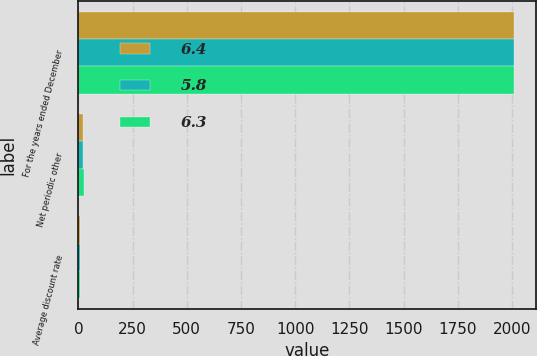Convert chart to OTSL. <chart><loc_0><loc_0><loc_500><loc_500><stacked_bar_chart><ecel><fcel>For the years ended December<fcel>Net periodic other<fcel>Average discount rate<nl><fcel>6.4<fcel>2009<fcel>19.9<fcel>6.4<nl><fcel>5.8<fcel>2008<fcel>21.9<fcel>6.3<nl><fcel>6.3<fcel>2007<fcel>24.9<fcel>5.8<nl></chart> 